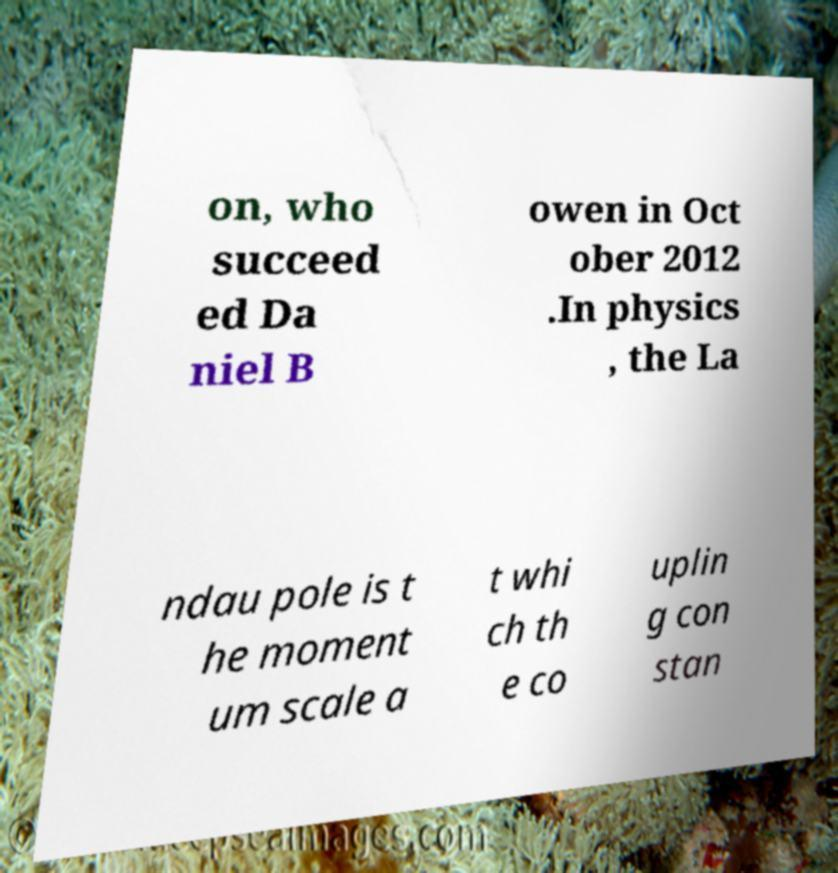Can you read and provide the text displayed in the image?This photo seems to have some interesting text. Can you extract and type it out for me? on, who succeed ed Da niel B owen in Oct ober 2012 .In physics , the La ndau pole is t he moment um scale a t whi ch th e co uplin g con stan 